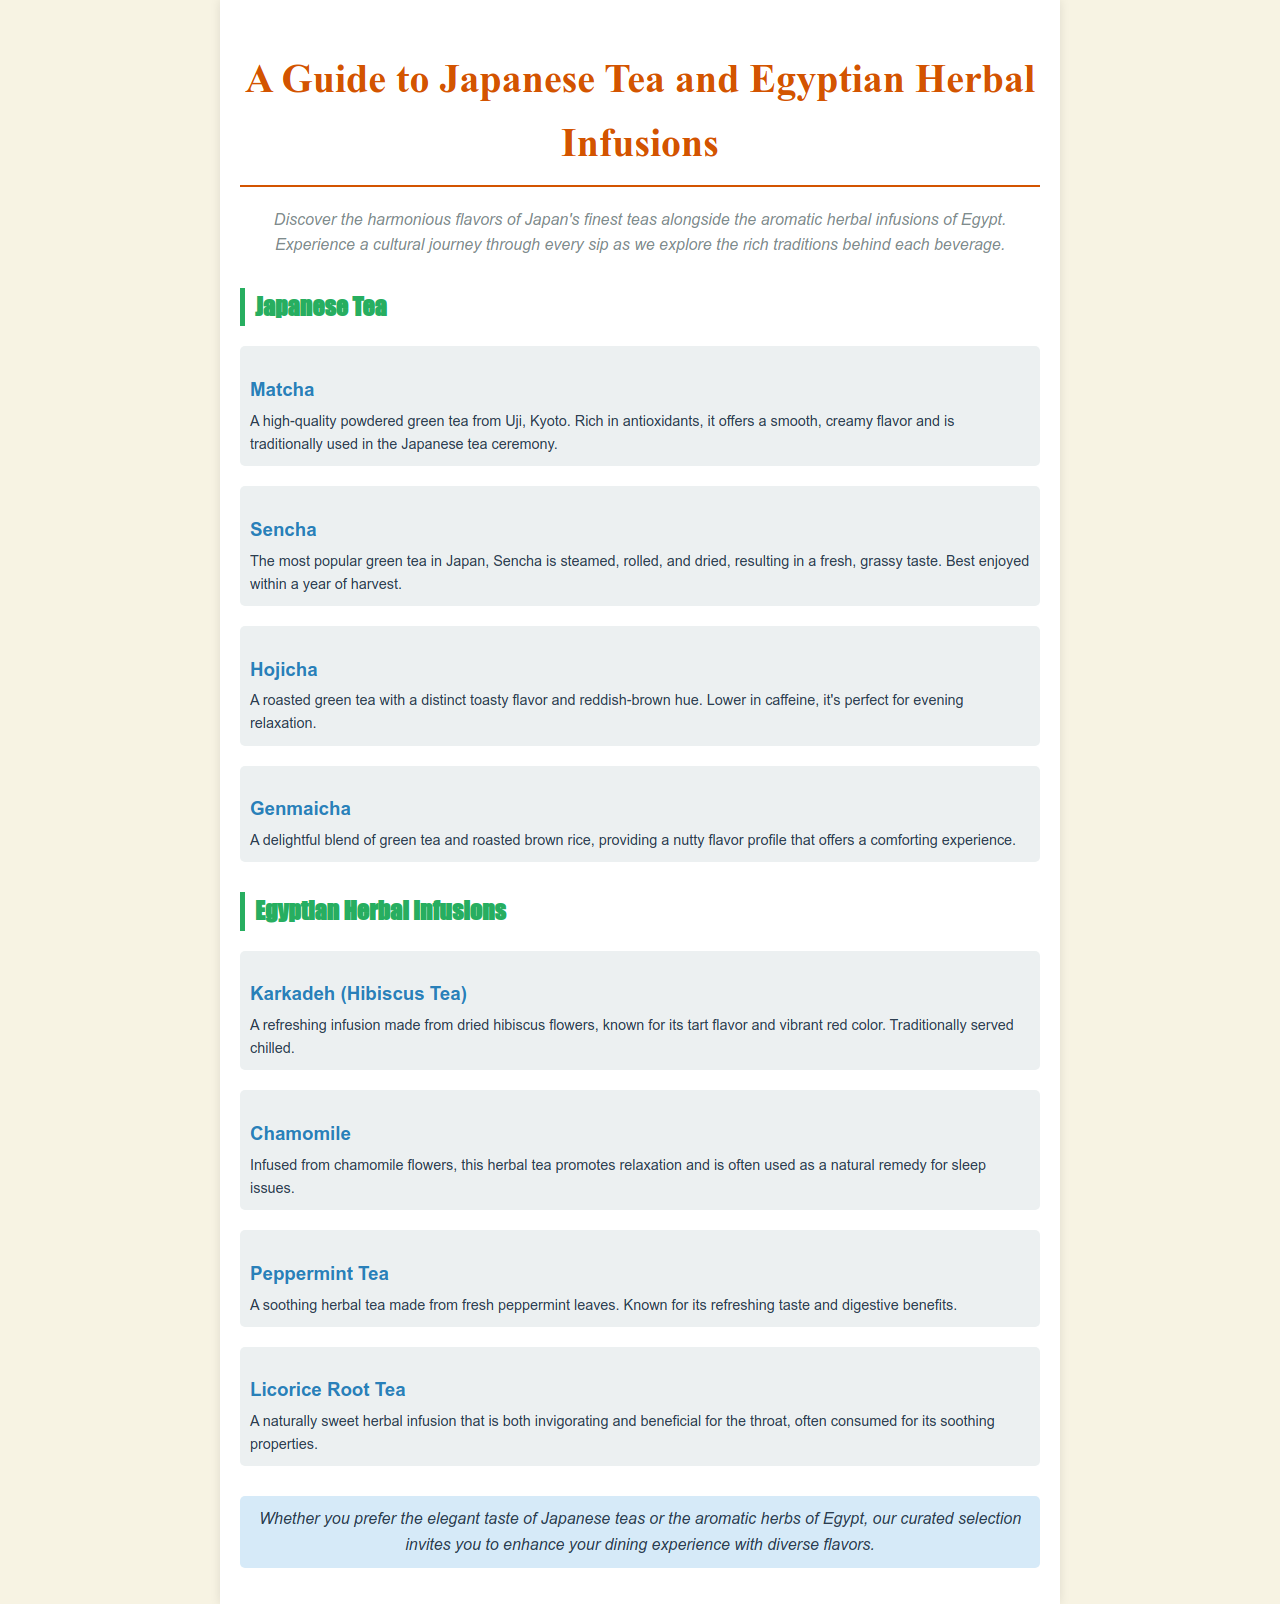What is the title of the guide? The title of the guide is clearly stated at the top of the document.
Answer: A Guide to Japanese Tea and Egyptian Herbal Infusions What type of tea is Matcha? The document specifies that Matcha is a high-quality powdered green tea.
Answer: powdered green tea What is the main flavor profile of Sencha? The document describes Sencha as having a fresh, grassy taste.
Answer: fresh, grassy taste Which Egyptian herbal infusion is made from dried hibiscus flowers? The document lists Karkadeh as the infusion made from hibiscus flowers.
Answer: Karkadeh What benefit is associated with Chamomile tea? The document states that Chamomile promotes relaxation and is used for sleep issues.
Answer: relaxation Which Japanese tea is described as lower in caffeine? The document indicates that Hojicha is lower in caffeine.
Answer: Hojicha What color is Karkadeh tea? The document mentions that Karkadeh has a vibrant red color.
Answer: vibrant red How is Genmaicha uniquely characterized? The document explains that Genmaicha is a blend of green tea and roasted brown rice.
Answer: blend of green tea and roasted brown rice Is Licorice Root Tea sweet or bitter? The document describes Licorice Root Tea as naturally sweet.
Answer: naturally sweet 